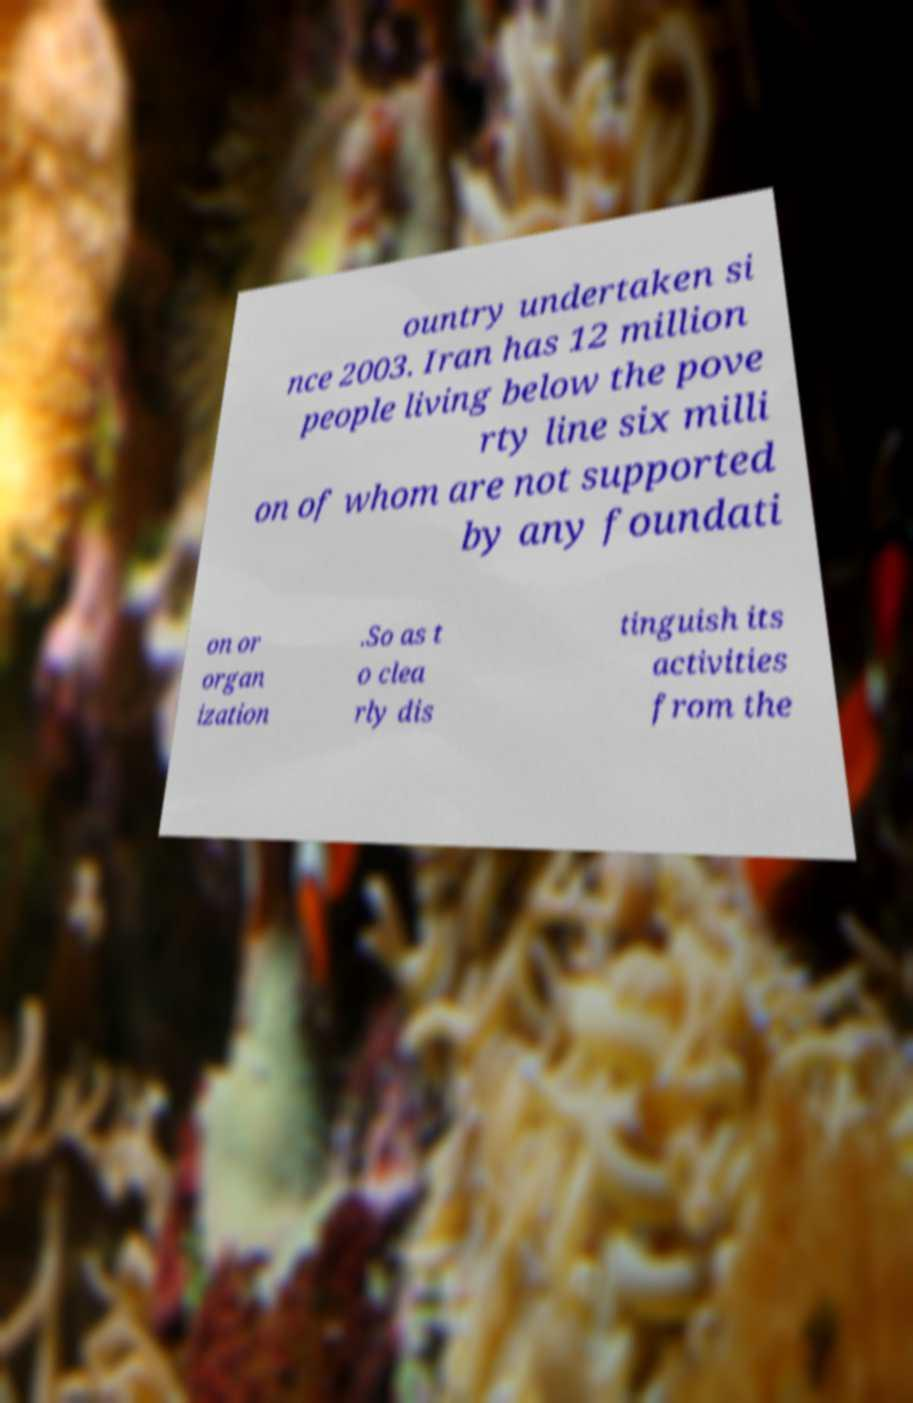What messages or text are displayed in this image? I need them in a readable, typed format. ountry undertaken si nce 2003. Iran has 12 million people living below the pove rty line six milli on of whom are not supported by any foundati on or organ ization .So as t o clea rly dis tinguish its activities from the 